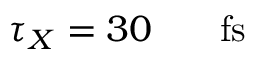<formula> <loc_0><loc_0><loc_500><loc_500>\tau _ { X } = 3 0 { { \, } } { f s }</formula> 